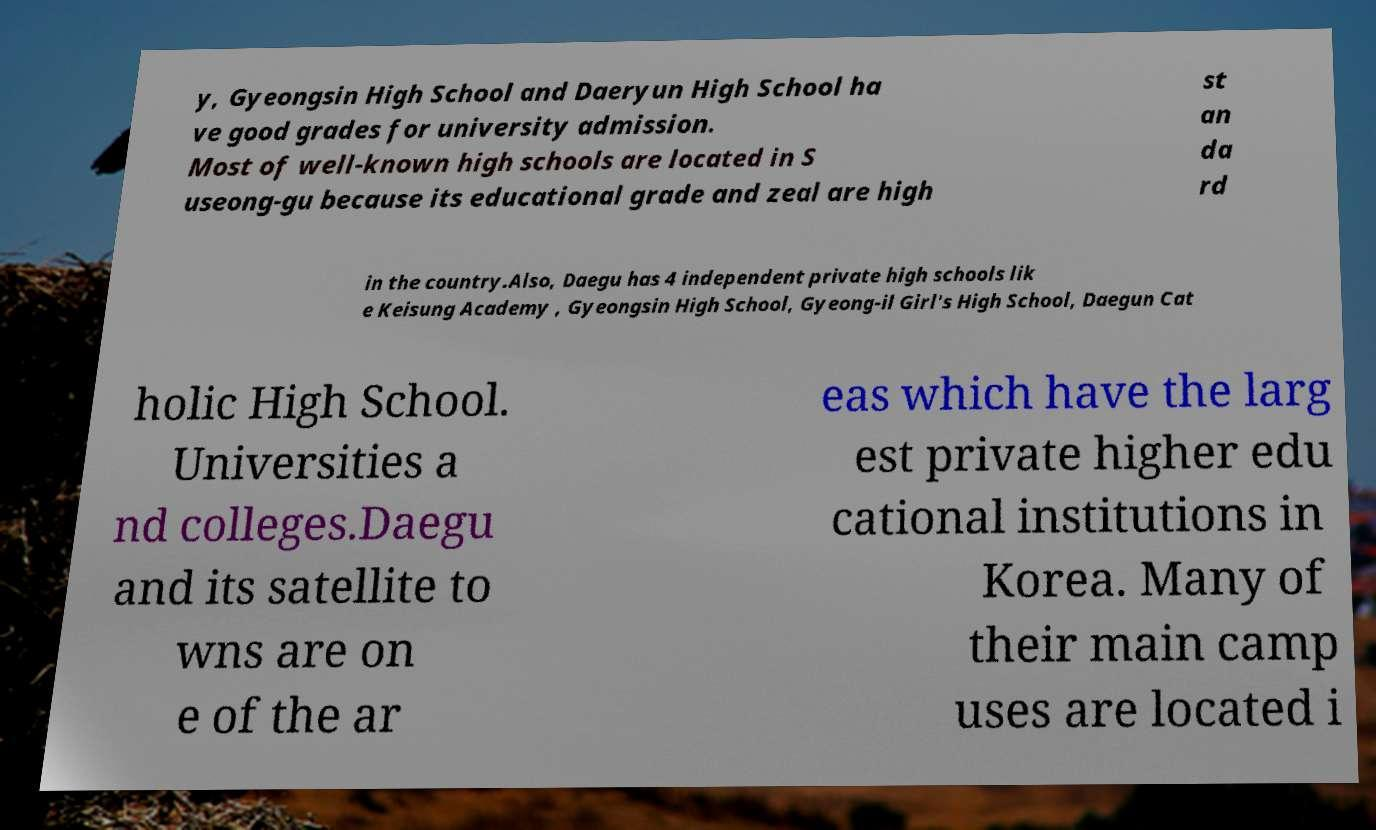There's text embedded in this image that I need extracted. Can you transcribe it verbatim? y, Gyeongsin High School and Daeryun High School ha ve good grades for university admission. Most of well-known high schools are located in S useong-gu because its educational grade and zeal are high st an da rd in the country.Also, Daegu has 4 independent private high schools lik e Keisung Academy , Gyeongsin High School, Gyeong-il Girl's High School, Daegun Cat holic High School. Universities a nd colleges.Daegu and its satellite to wns are on e of the ar eas which have the larg est private higher edu cational institutions in Korea. Many of their main camp uses are located i 